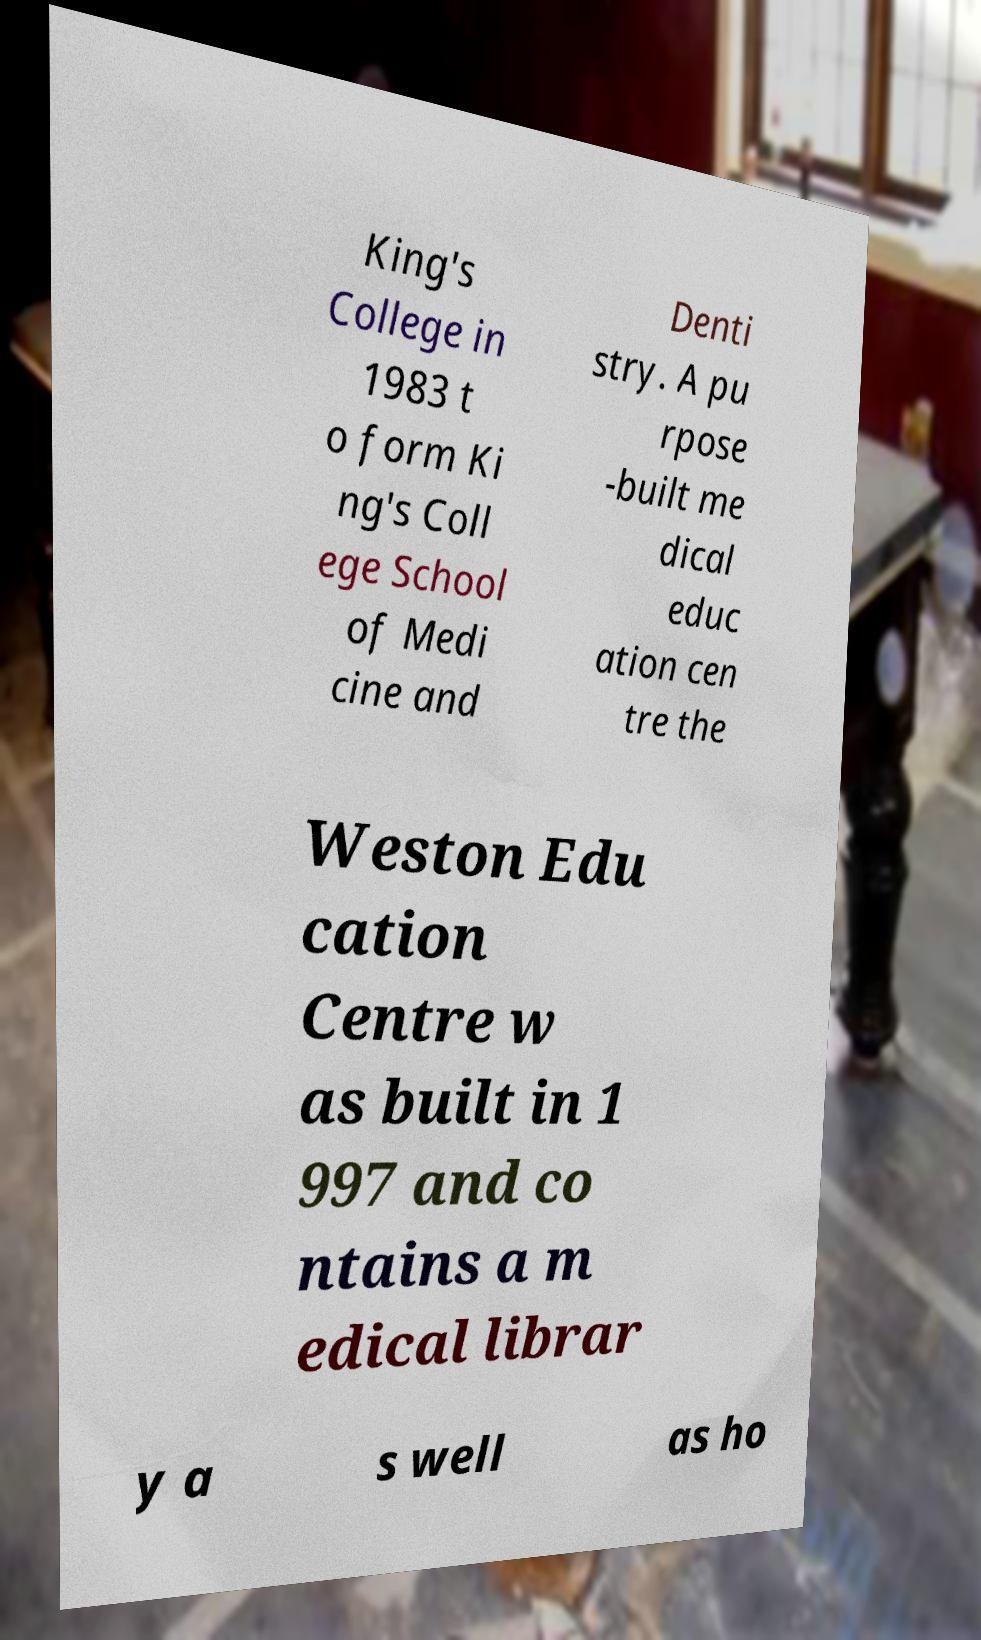I need the written content from this picture converted into text. Can you do that? King's College in 1983 t o form Ki ng's Coll ege School of Medi cine and Denti stry. A pu rpose -built me dical educ ation cen tre the Weston Edu cation Centre w as built in 1 997 and co ntains a m edical librar y a s well as ho 